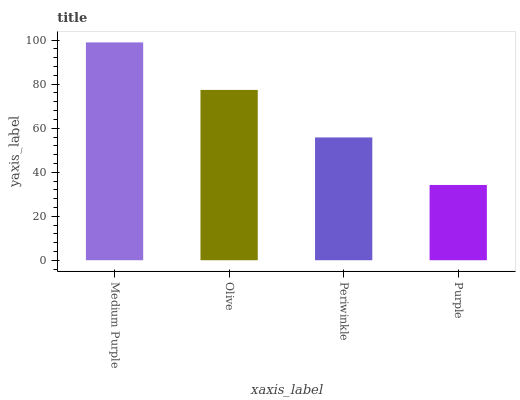Is Olive the minimum?
Answer yes or no. No. Is Olive the maximum?
Answer yes or no. No. Is Medium Purple greater than Olive?
Answer yes or no. Yes. Is Olive less than Medium Purple?
Answer yes or no. Yes. Is Olive greater than Medium Purple?
Answer yes or no. No. Is Medium Purple less than Olive?
Answer yes or no. No. Is Olive the high median?
Answer yes or no. Yes. Is Periwinkle the low median?
Answer yes or no. Yes. Is Periwinkle the high median?
Answer yes or no. No. Is Medium Purple the low median?
Answer yes or no. No. 